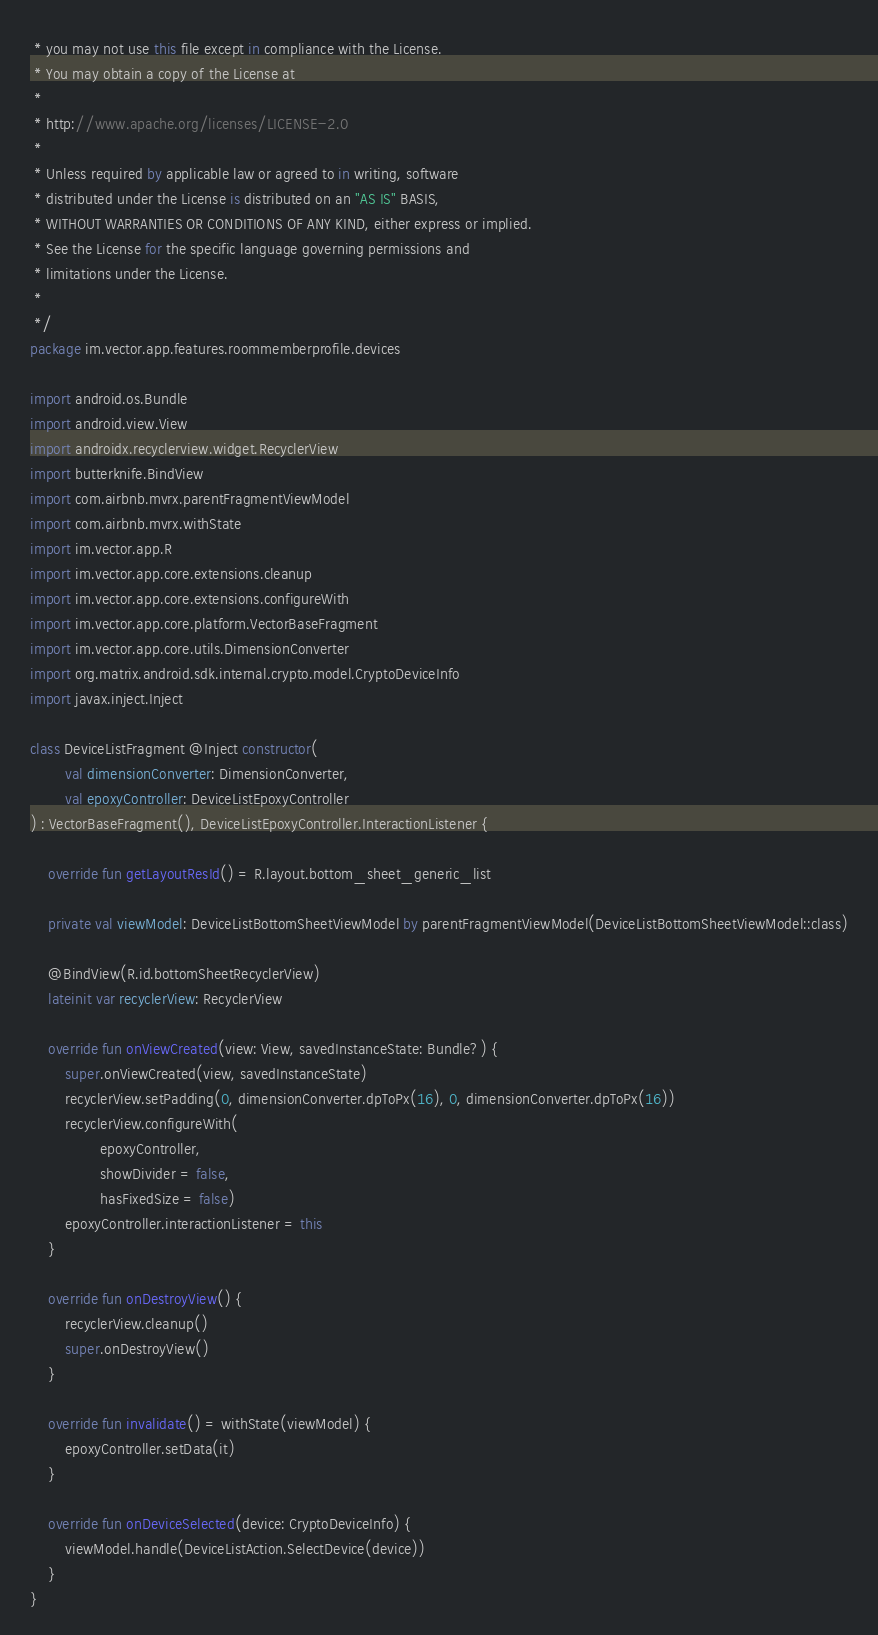Convert code to text. <code><loc_0><loc_0><loc_500><loc_500><_Kotlin_> * you may not use this file except in compliance with the License.
 * You may obtain a copy of the License at
 *
 * http://www.apache.org/licenses/LICENSE-2.0
 *
 * Unless required by applicable law or agreed to in writing, software
 * distributed under the License is distributed on an "AS IS" BASIS,
 * WITHOUT WARRANTIES OR CONDITIONS OF ANY KIND, either express or implied.
 * See the License for the specific language governing permissions and
 * limitations under the License.
 *
 */
package im.vector.app.features.roommemberprofile.devices

import android.os.Bundle
import android.view.View
import androidx.recyclerview.widget.RecyclerView
import butterknife.BindView
import com.airbnb.mvrx.parentFragmentViewModel
import com.airbnb.mvrx.withState
import im.vector.app.R
import im.vector.app.core.extensions.cleanup
import im.vector.app.core.extensions.configureWith
import im.vector.app.core.platform.VectorBaseFragment
import im.vector.app.core.utils.DimensionConverter
import org.matrix.android.sdk.internal.crypto.model.CryptoDeviceInfo
import javax.inject.Inject

class DeviceListFragment @Inject constructor(
        val dimensionConverter: DimensionConverter,
        val epoxyController: DeviceListEpoxyController
) : VectorBaseFragment(), DeviceListEpoxyController.InteractionListener {

    override fun getLayoutResId() = R.layout.bottom_sheet_generic_list

    private val viewModel: DeviceListBottomSheetViewModel by parentFragmentViewModel(DeviceListBottomSheetViewModel::class)

    @BindView(R.id.bottomSheetRecyclerView)
    lateinit var recyclerView: RecyclerView

    override fun onViewCreated(view: View, savedInstanceState: Bundle?) {
        super.onViewCreated(view, savedInstanceState)
        recyclerView.setPadding(0, dimensionConverter.dpToPx(16), 0, dimensionConverter.dpToPx(16))
        recyclerView.configureWith(
                epoxyController,
                showDivider = false,
                hasFixedSize = false)
        epoxyController.interactionListener = this
    }

    override fun onDestroyView() {
        recyclerView.cleanup()
        super.onDestroyView()
    }

    override fun invalidate() = withState(viewModel) {
        epoxyController.setData(it)
    }

    override fun onDeviceSelected(device: CryptoDeviceInfo) {
        viewModel.handle(DeviceListAction.SelectDevice(device))
    }
}
</code> 